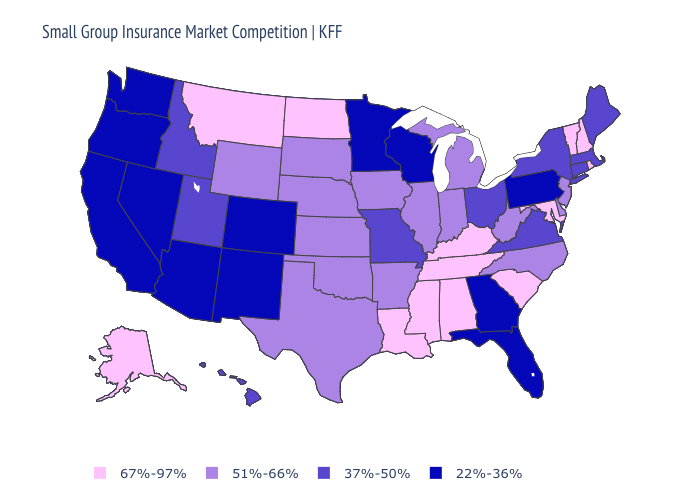Name the states that have a value in the range 51%-66%?
Be succinct. Arkansas, Delaware, Illinois, Indiana, Iowa, Kansas, Michigan, Nebraska, New Jersey, North Carolina, Oklahoma, South Dakota, Texas, West Virginia, Wyoming. How many symbols are there in the legend?
Keep it brief. 4. Does Oregon have the highest value in the West?
Answer briefly. No. Among the states that border Ohio , which have the highest value?
Answer briefly. Kentucky. Does Michigan have the highest value in the USA?
Concise answer only. No. Name the states that have a value in the range 67%-97%?
Write a very short answer. Alabama, Alaska, Kentucky, Louisiana, Maryland, Mississippi, Montana, New Hampshire, North Dakota, Rhode Island, South Carolina, Tennessee, Vermont. Does Pennsylvania have the lowest value in the Northeast?
Be succinct. Yes. What is the value of Kansas?
Give a very brief answer. 51%-66%. Among the states that border Ohio , does Pennsylvania have the lowest value?
Keep it brief. Yes. What is the value of North Dakota?
Keep it brief. 67%-97%. Which states have the lowest value in the USA?
Keep it brief. Arizona, California, Colorado, Florida, Georgia, Minnesota, Nevada, New Mexico, Oregon, Pennsylvania, Washington, Wisconsin. Name the states that have a value in the range 37%-50%?
Short answer required. Connecticut, Hawaii, Idaho, Maine, Massachusetts, Missouri, New York, Ohio, Utah, Virginia. What is the value of California?
Quick response, please. 22%-36%. What is the value of New Mexico?
Answer briefly. 22%-36%. 